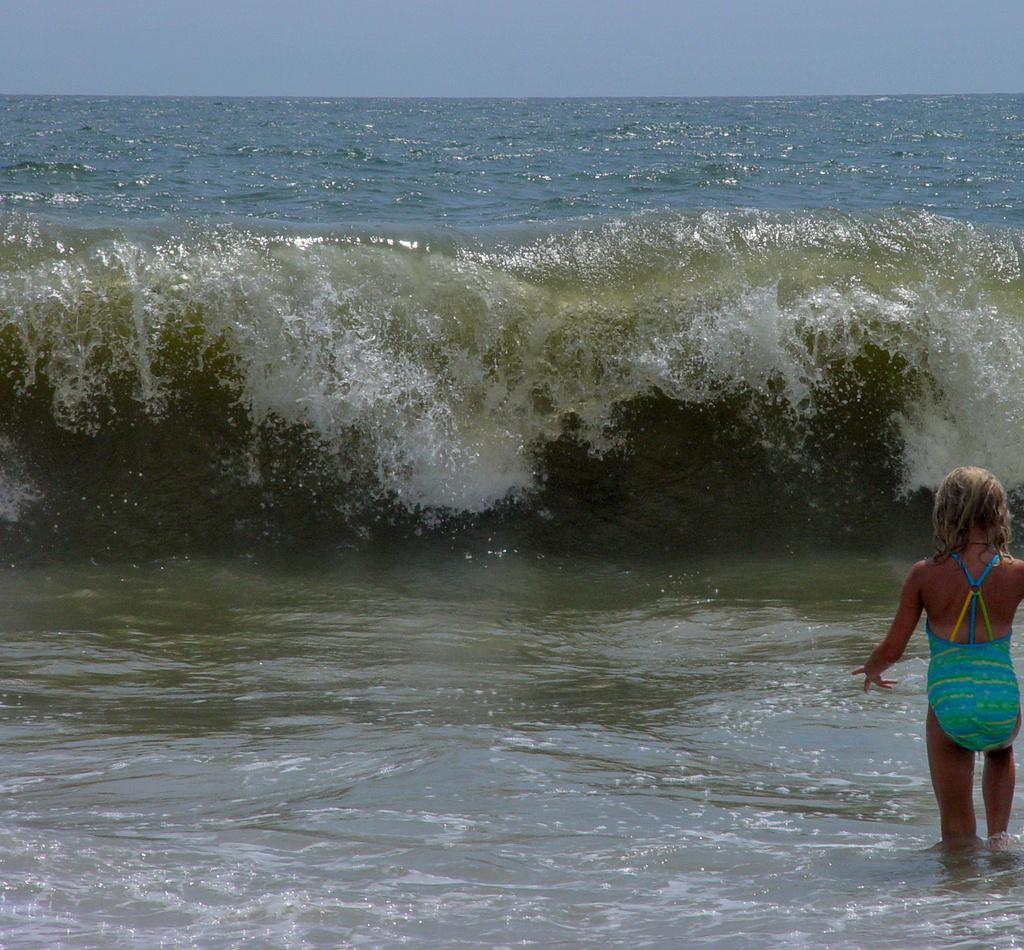What is the girl doing in the image? The girl is standing in the water. What can be seen in the background of the image? The sky is visible in the background of the image. What type of care does the girl need for her wrench in the image? There is no wrench present in the image, so the girl does not need any care for a wrench. 